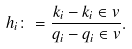<formula> <loc_0><loc_0><loc_500><loc_500>h _ { i } \colon = \frac { k _ { i } - { k _ { i } } \in v } { q _ { i } - { q _ { i } } \in v } .</formula> 